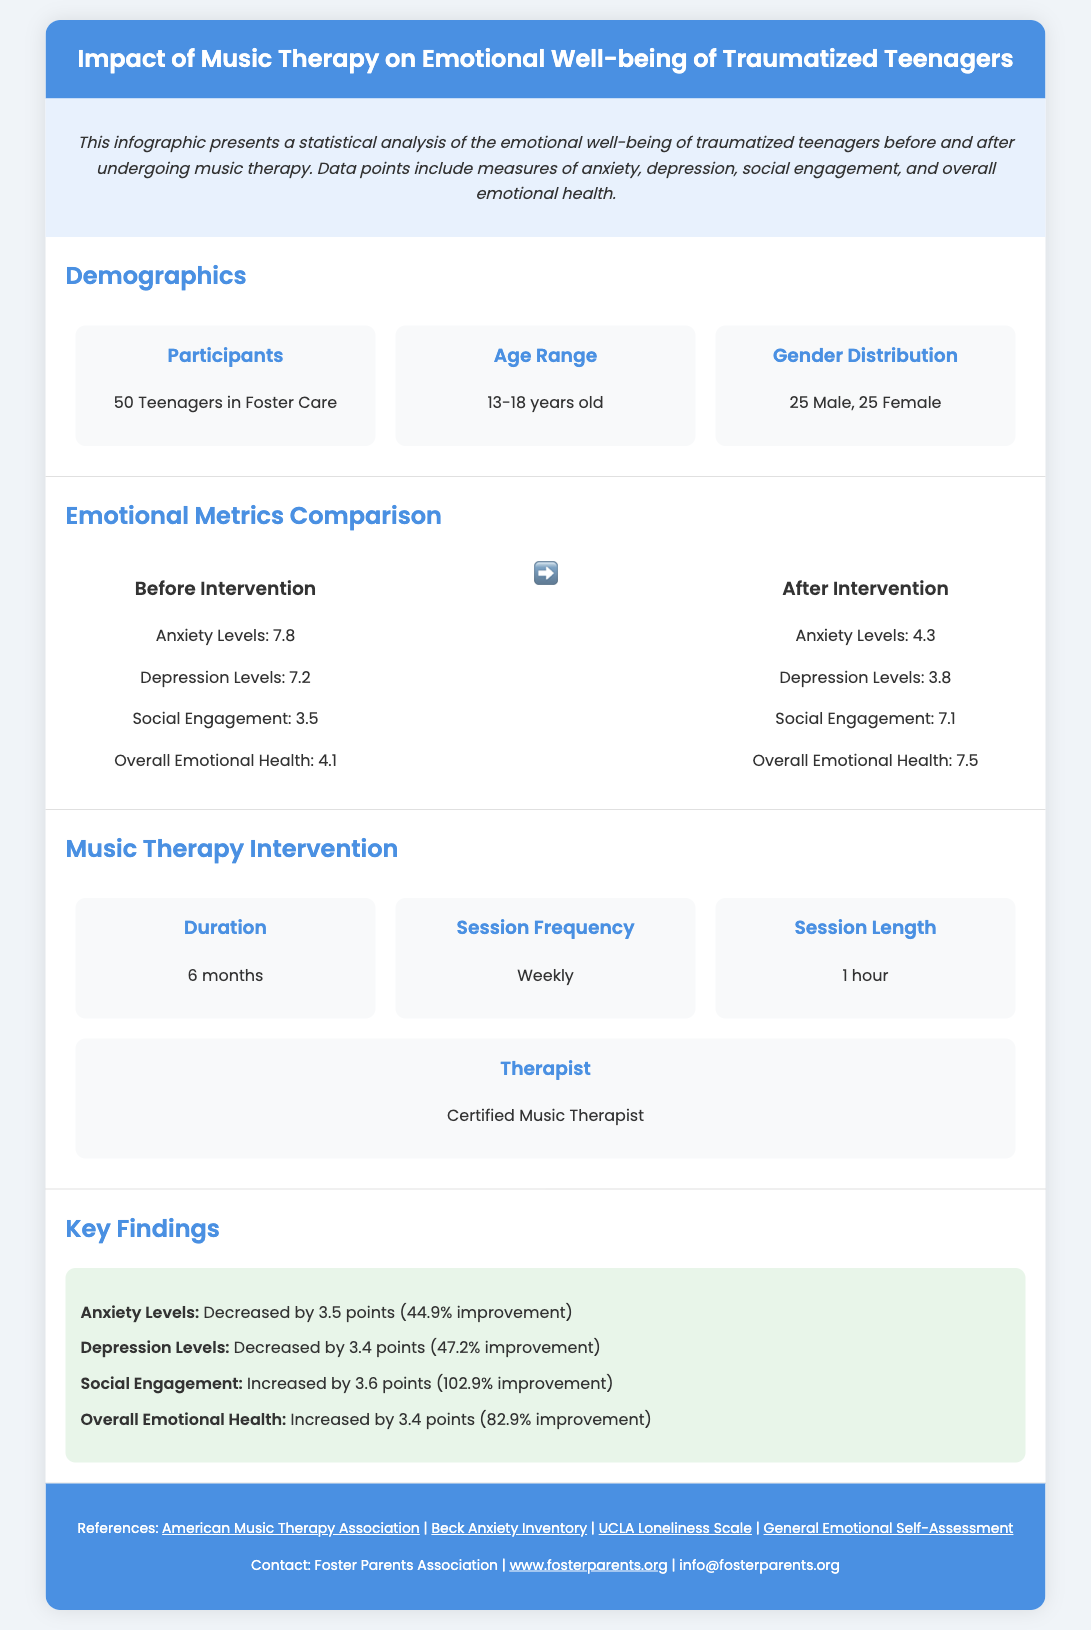What was the age range of the participants? The age range of the participants is listed as 13-18 years old in the demographics section.
Answer: 13-18 years old How many participants were there in total? The total number of participants in the study is stated as 50 Teenagers in Foster Care.
Answer: 50 Teenagers in Foster Care What was the anxiety level before the intervention? The anxiety level before the intervention is provided in the emotional metrics comparison section and is noted as 7.8.
Answer: 7.8 What improvement percentage did social engagement see after the intervention? The improvement percentage in social engagement is mentioned in the key findings section as 102.9%.
Answer: 102.9% Who conducted the music therapy sessions? The therapist conducting the sessions is described in the music therapy intervention section as a Certified Music Therapist.
Answer: Certified Music Therapist What was the duration of the music therapy intervention? The duration of the music therapy intervention is specified in the music therapy intervention section as 6 months.
Answer: 6 months What was the overall emotional health level after the intervention? The overall emotional health level after the intervention is mentioned in the emotional metrics comparison section as 7.5.
Answer: 7.5 What was the decrease in depression levels after the intervention? The decrease in depression levels after the intervention is noted in the key findings section as 3.4 points.
Answer: 3.4 points How often did the music therapy sessions occur? The frequency of the sessions is detailed in the music therapy intervention section as weekly.
Answer: Weekly 